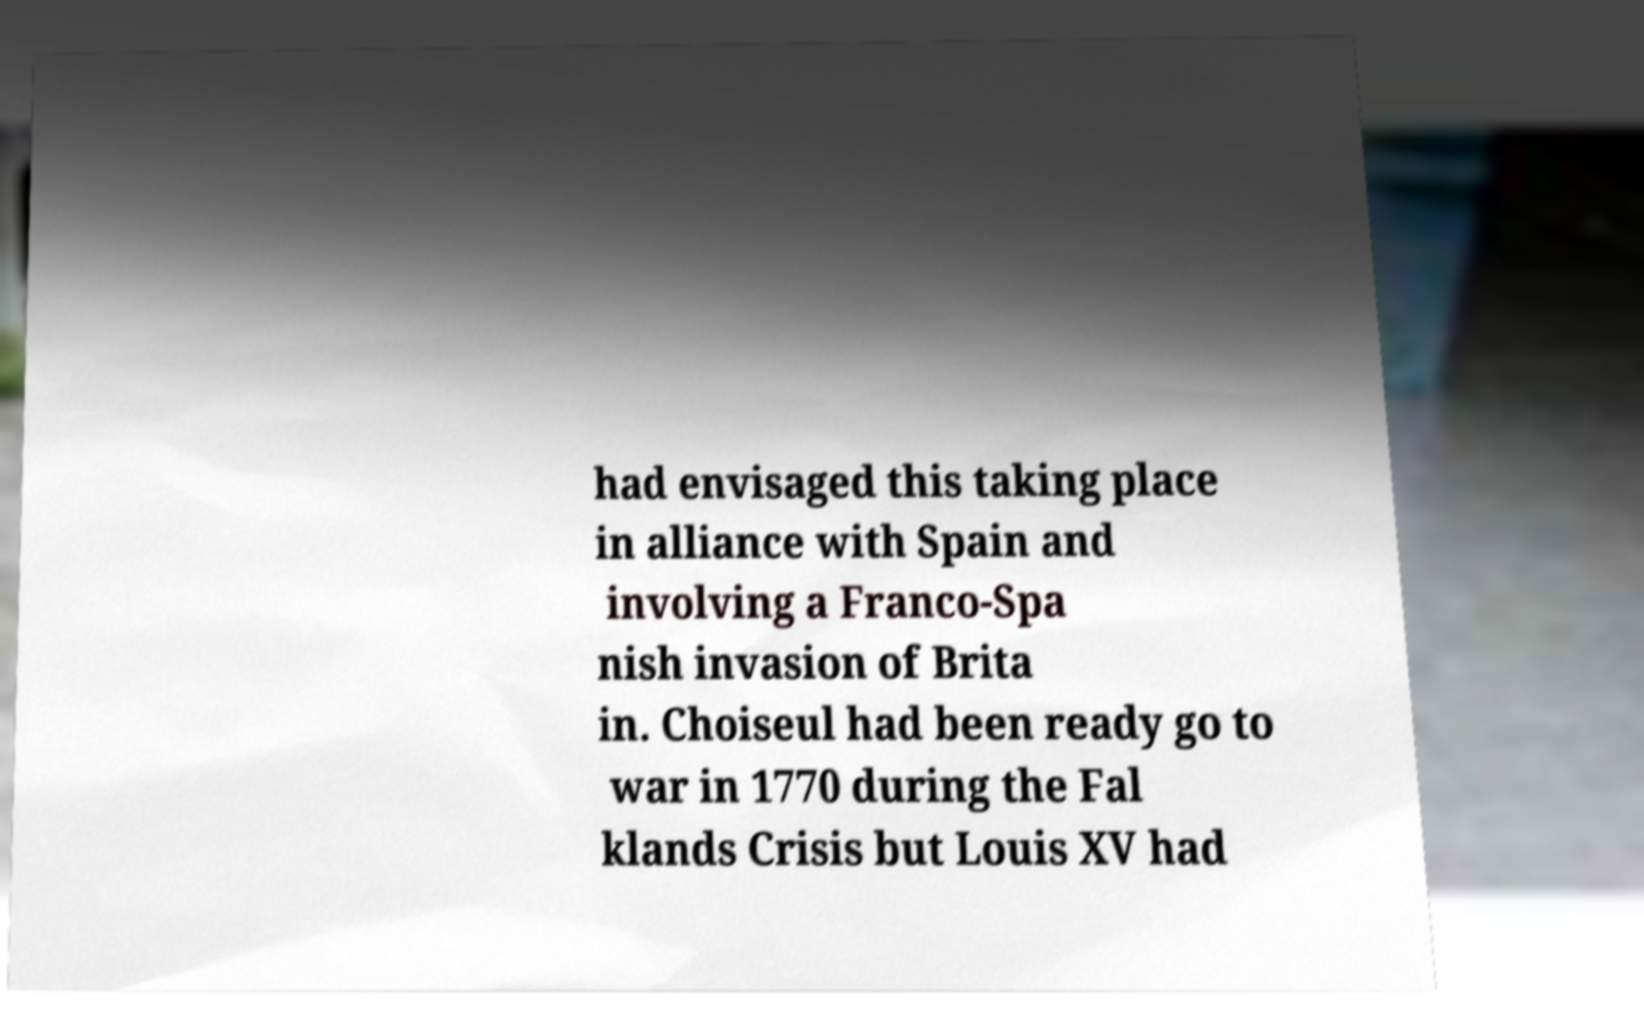Could you assist in decoding the text presented in this image and type it out clearly? had envisaged this taking place in alliance with Spain and involving a Franco-Spa nish invasion of Brita in. Choiseul had been ready go to war in 1770 during the Fal klands Crisis but Louis XV had 